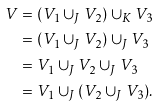<formula> <loc_0><loc_0><loc_500><loc_500>V & = ( V _ { 1 } \cup _ { J } V _ { 2 } ) \cup _ { K } V _ { 3 } \\ & = ( V _ { 1 } \cup _ { J } V _ { 2 } ) \cup _ { J } V _ { 3 } \\ & = V _ { 1 } \cup _ { J } V _ { 2 } \cup _ { J } V _ { 3 } \\ & = V _ { 1 } \cup _ { J } ( V _ { 2 } \cup _ { J } V _ { 3 } ) .</formula> 